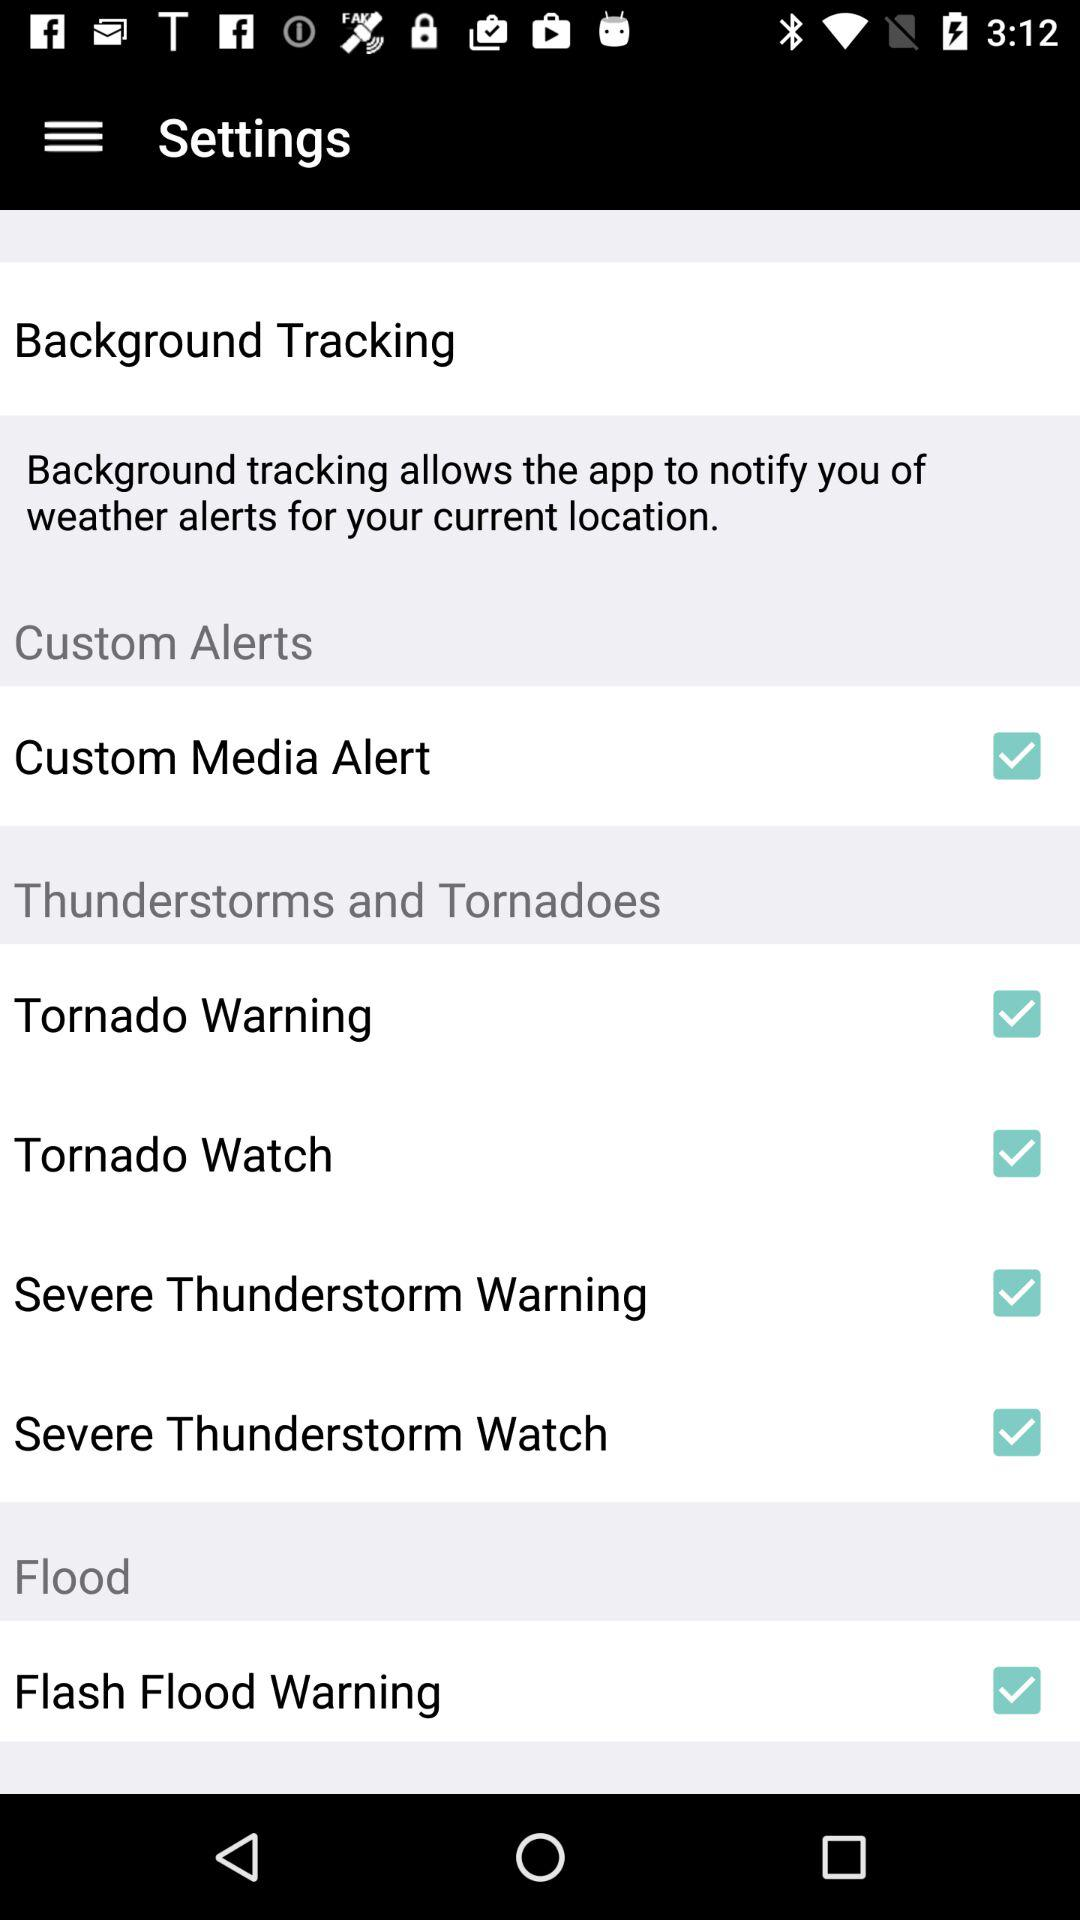How many more items are in the 'Thunderstorms and Tornadoes' section than in the 'Custom Alerts' section?
Answer the question using a single word or phrase. 3 